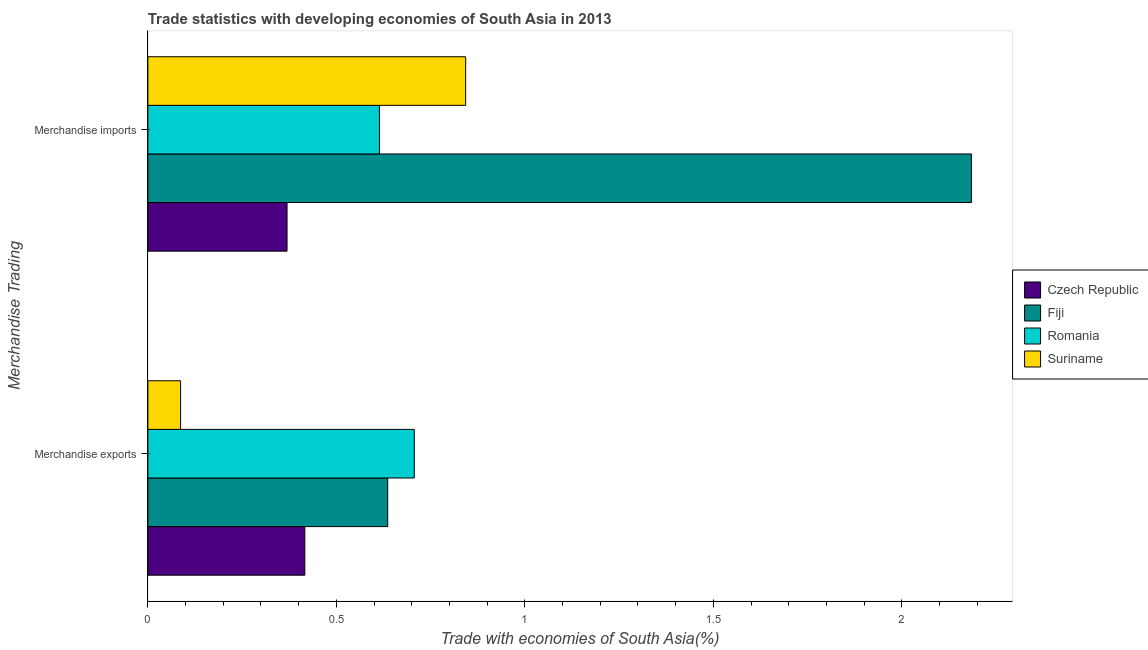How many different coloured bars are there?
Provide a succinct answer. 4. How many groups of bars are there?
Provide a succinct answer. 2. How many bars are there on the 1st tick from the top?
Give a very brief answer. 4. What is the merchandise exports in Czech Republic?
Offer a very short reply. 0.42. Across all countries, what is the maximum merchandise exports?
Your answer should be very brief. 0.71. Across all countries, what is the minimum merchandise imports?
Ensure brevity in your answer.  0.37. In which country was the merchandise exports maximum?
Keep it short and to the point. Romania. In which country was the merchandise exports minimum?
Offer a very short reply. Suriname. What is the total merchandise imports in the graph?
Give a very brief answer. 4.01. What is the difference between the merchandise exports in Czech Republic and that in Suriname?
Provide a short and direct response. 0.33. What is the difference between the merchandise exports in Romania and the merchandise imports in Czech Republic?
Provide a short and direct response. 0.34. What is the average merchandise imports per country?
Make the answer very short. 1. What is the difference between the merchandise imports and merchandise exports in Czech Republic?
Provide a short and direct response. -0.05. What is the ratio of the merchandise exports in Fiji to that in Romania?
Keep it short and to the point. 0.9. Is the merchandise imports in Czech Republic less than that in Suriname?
Offer a terse response. Yes. In how many countries, is the merchandise exports greater than the average merchandise exports taken over all countries?
Your answer should be very brief. 2. What does the 2nd bar from the top in Merchandise imports represents?
Offer a terse response. Romania. What does the 4th bar from the bottom in Merchandise imports represents?
Give a very brief answer. Suriname. How many bars are there?
Make the answer very short. 8. Are all the bars in the graph horizontal?
Provide a succinct answer. Yes. What is the difference between two consecutive major ticks on the X-axis?
Ensure brevity in your answer.  0.5. Does the graph contain any zero values?
Give a very brief answer. No. Does the graph contain grids?
Your answer should be compact. No. Where does the legend appear in the graph?
Ensure brevity in your answer.  Center right. How many legend labels are there?
Your answer should be compact. 4. What is the title of the graph?
Provide a short and direct response. Trade statistics with developing economies of South Asia in 2013. Does "Argentina" appear as one of the legend labels in the graph?
Give a very brief answer. No. What is the label or title of the X-axis?
Ensure brevity in your answer.  Trade with economies of South Asia(%). What is the label or title of the Y-axis?
Offer a terse response. Merchandise Trading. What is the Trade with economies of South Asia(%) in Czech Republic in Merchandise exports?
Ensure brevity in your answer.  0.42. What is the Trade with economies of South Asia(%) of Fiji in Merchandise exports?
Provide a succinct answer. 0.64. What is the Trade with economies of South Asia(%) in Romania in Merchandise exports?
Your response must be concise. 0.71. What is the Trade with economies of South Asia(%) in Suriname in Merchandise exports?
Your response must be concise. 0.09. What is the Trade with economies of South Asia(%) in Czech Republic in Merchandise imports?
Provide a succinct answer. 0.37. What is the Trade with economies of South Asia(%) of Fiji in Merchandise imports?
Your answer should be very brief. 2.18. What is the Trade with economies of South Asia(%) of Romania in Merchandise imports?
Provide a short and direct response. 0.61. What is the Trade with economies of South Asia(%) in Suriname in Merchandise imports?
Ensure brevity in your answer.  0.84. Across all Merchandise Trading, what is the maximum Trade with economies of South Asia(%) of Czech Republic?
Offer a terse response. 0.42. Across all Merchandise Trading, what is the maximum Trade with economies of South Asia(%) in Fiji?
Your response must be concise. 2.18. Across all Merchandise Trading, what is the maximum Trade with economies of South Asia(%) of Romania?
Give a very brief answer. 0.71. Across all Merchandise Trading, what is the maximum Trade with economies of South Asia(%) of Suriname?
Give a very brief answer. 0.84. Across all Merchandise Trading, what is the minimum Trade with economies of South Asia(%) in Czech Republic?
Your response must be concise. 0.37. Across all Merchandise Trading, what is the minimum Trade with economies of South Asia(%) of Fiji?
Keep it short and to the point. 0.64. Across all Merchandise Trading, what is the minimum Trade with economies of South Asia(%) of Romania?
Your answer should be compact. 0.61. Across all Merchandise Trading, what is the minimum Trade with economies of South Asia(%) of Suriname?
Keep it short and to the point. 0.09. What is the total Trade with economies of South Asia(%) in Czech Republic in the graph?
Provide a succinct answer. 0.79. What is the total Trade with economies of South Asia(%) in Fiji in the graph?
Offer a terse response. 2.82. What is the total Trade with economies of South Asia(%) in Romania in the graph?
Provide a succinct answer. 1.32. What is the total Trade with economies of South Asia(%) in Suriname in the graph?
Your answer should be compact. 0.93. What is the difference between the Trade with economies of South Asia(%) of Czech Republic in Merchandise exports and that in Merchandise imports?
Your answer should be very brief. 0.05. What is the difference between the Trade with economies of South Asia(%) of Fiji in Merchandise exports and that in Merchandise imports?
Provide a succinct answer. -1.55. What is the difference between the Trade with economies of South Asia(%) in Romania in Merchandise exports and that in Merchandise imports?
Make the answer very short. 0.09. What is the difference between the Trade with economies of South Asia(%) in Suriname in Merchandise exports and that in Merchandise imports?
Keep it short and to the point. -0.76. What is the difference between the Trade with economies of South Asia(%) of Czech Republic in Merchandise exports and the Trade with economies of South Asia(%) of Fiji in Merchandise imports?
Your answer should be very brief. -1.77. What is the difference between the Trade with economies of South Asia(%) in Czech Republic in Merchandise exports and the Trade with economies of South Asia(%) in Romania in Merchandise imports?
Provide a succinct answer. -0.2. What is the difference between the Trade with economies of South Asia(%) in Czech Republic in Merchandise exports and the Trade with economies of South Asia(%) in Suriname in Merchandise imports?
Your answer should be very brief. -0.43. What is the difference between the Trade with economies of South Asia(%) of Fiji in Merchandise exports and the Trade with economies of South Asia(%) of Romania in Merchandise imports?
Keep it short and to the point. 0.02. What is the difference between the Trade with economies of South Asia(%) of Fiji in Merchandise exports and the Trade with economies of South Asia(%) of Suriname in Merchandise imports?
Your response must be concise. -0.21. What is the difference between the Trade with economies of South Asia(%) in Romania in Merchandise exports and the Trade with economies of South Asia(%) in Suriname in Merchandise imports?
Ensure brevity in your answer.  -0.14. What is the average Trade with economies of South Asia(%) in Czech Republic per Merchandise Trading?
Provide a succinct answer. 0.39. What is the average Trade with economies of South Asia(%) in Fiji per Merchandise Trading?
Offer a very short reply. 1.41. What is the average Trade with economies of South Asia(%) of Romania per Merchandise Trading?
Offer a very short reply. 0.66. What is the average Trade with economies of South Asia(%) of Suriname per Merchandise Trading?
Give a very brief answer. 0.46. What is the difference between the Trade with economies of South Asia(%) in Czech Republic and Trade with economies of South Asia(%) in Fiji in Merchandise exports?
Offer a very short reply. -0.22. What is the difference between the Trade with economies of South Asia(%) in Czech Republic and Trade with economies of South Asia(%) in Romania in Merchandise exports?
Keep it short and to the point. -0.29. What is the difference between the Trade with economies of South Asia(%) in Czech Republic and Trade with economies of South Asia(%) in Suriname in Merchandise exports?
Offer a terse response. 0.33. What is the difference between the Trade with economies of South Asia(%) of Fiji and Trade with economies of South Asia(%) of Romania in Merchandise exports?
Make the answer very short. -0.07. What is the difference between the Trade with economies of South Asia(%) of Fiji and Trade with economies of South Asia(%) of Suriname in Merchandise exports?
Offer a very short reply. 0.55. What is the difference between the Trade with economies of South Asia(%) in Romania and Trade with economies of South Asia(%) in Suriname in Merchandise exports?
Provide a short and direct response. 0.62. What is the difference between the Trade with economies of South Asia(%) of Czech Republic and Trade with economies of South Asia(%) of Fiji in Merchandise imports?
Provide a succinct answer. -1.82. What is the difference between the Trade with economies of South Asia(%) in Czech Republic and Trade with economies of South Asia(%) in Romania in Merchandise imports?
Offer a terse response. -0.25. What is the difference between the Trade with economies of South Asia(%) of Czech Republic and Trade with economies of South Asia(%) of Suriname in Merchandise imports?
Ensure brevity in your answer.  -0.47. What is the difference between the Trade with economies of South Asia(%) in Fiji and Trade with economies of South Asia(%) in Romania in Merchandise imports?
Offer a very short reply. 1.57. What is the difference between the Trade with economies of South Asia(%) in Fiji and Trade with economies of South Asia(%) in Suriname in Merchandise imports?
Ensure brevity in your answer.  1.34. What is the difference between the Trade with economies of South Asia(%) of Romania and Trade with economies of South Asia(%) of Suriname in Merchandise imports?
Make the answer very short. -0.23. What is the ratio of the Trade with economies of South Asia(%) in Czech Republic in Merchandise exports to that in Merchandise imports?
Give a very brief answer. 1.13. What is the ratio of the Trade with economies of South Asia(%) of Fiji in Merchandise exports to that in Merchandise imports?
Your response must be concise. 0.29. What is the ratio of the Trade with economies of South Asia(%) in Romania in Merchandise exports to that in Merchandise imports?
Ensure brevity in your answer.  1.15. What is the ratio of the Trade with economies of South Asia(%) of Suriname in Merchandise exports to that in Merchandise imports?
Offer a terse response. 0.1. What is the difference between the highest and the second highest Trade with economies of South Asia(%) in Czech Republic?
Your response must be concise. 0.05. What is the difference between the highest and the second highest Trade with economies of South Asia(%) in Fiji?
Your answer should be very brief. 1.55. What is the difference between the highest and the second highest Trade with economies of South Asia(%) in Romania?
Give a very brief answer. 0.09. What is the difference between the highest and the second highest Trade with economies of South Asia(%) of Suriname?
Your response must be concise. 0.76. What is the difference between the highest and the lowest Trade with economies of South Asia(%) of Czech Republic?
Keep it short and to the point. 0.05. What is the difference between the highest and the lowest Trade with economies of South Asia(%) of Fiji?
Keep it short and to the point. 1.55. What is the difference between the highest and the lowest Trade with economies of South Asia(%) of Romania?
Ensure brevity in your answer.  0.09. What is the difference between the highest and the lowest Trade with economies of South Asia(%) of Suriname?
Keep it short and to the point. 0.76. 